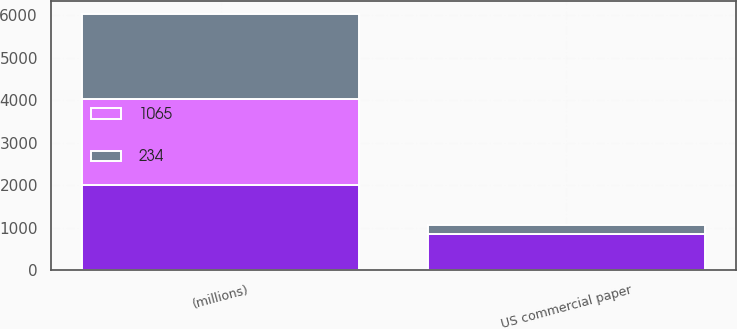<chart> <loc_0><loc_0><loc_500><loc_500><stacked_bar_chart><ecel><fcel>(millions)<fcel>US commercial paper<nl><fcel>nan<fcel>2012<fcel>853<nl><fcel>1065<fcel>2012<fcel>0.26<nl><fcel>234<fcel>2011<fcel>216<nl></chart> 